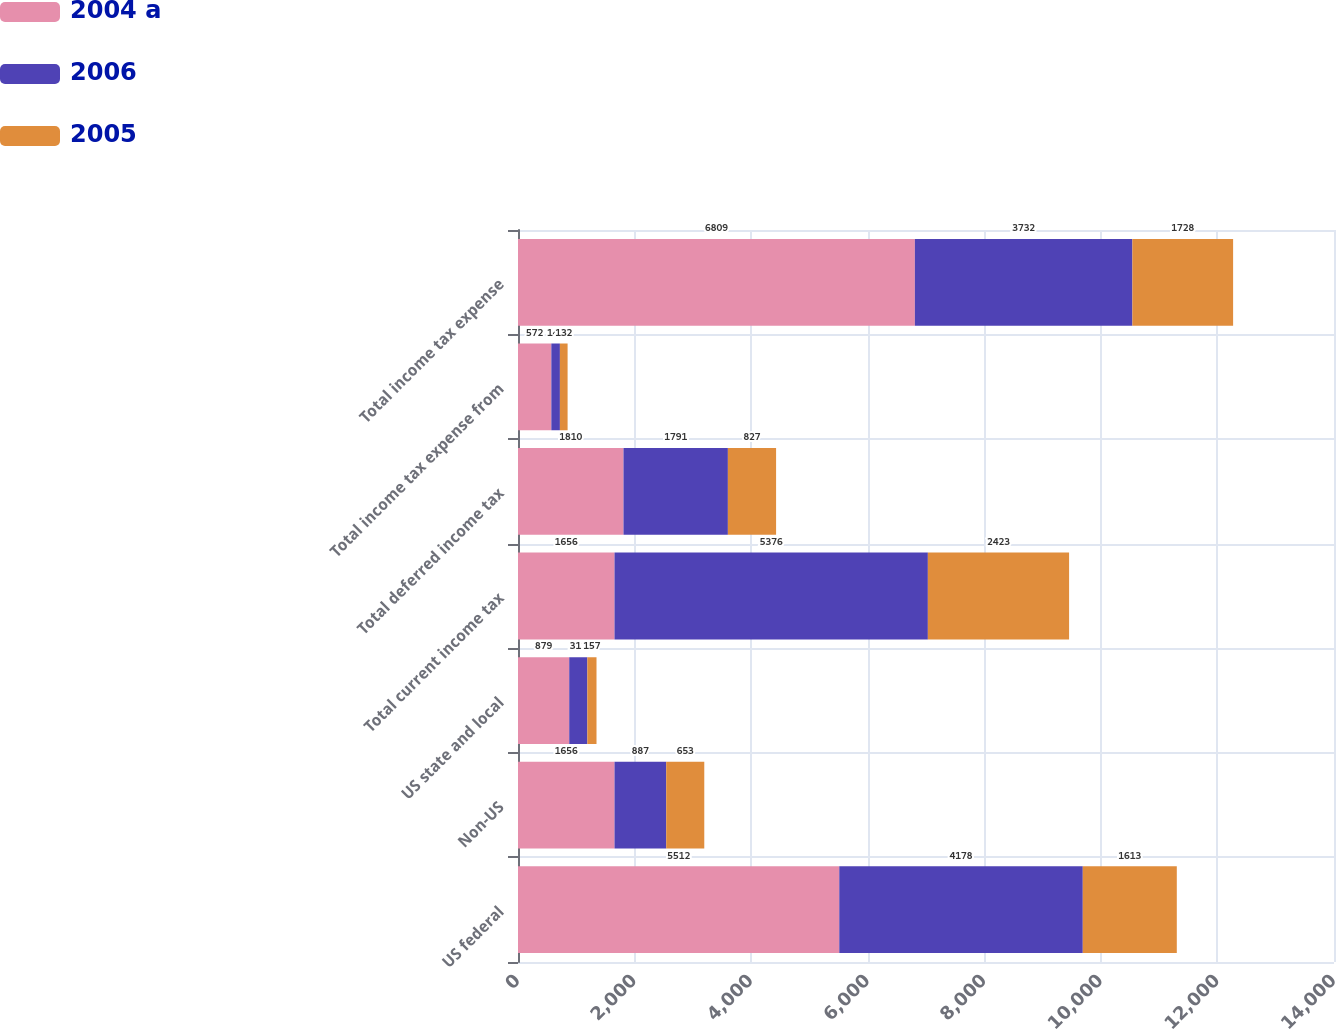<chart> <loc_0><loc_0><loc_500><loc_500><stacked_bar_chart><ecel><fcel>US federal<fcel>Non-US<fcel>US state and local<fcel>Total current income tax<fcel>Total deferred income tax<fcel>Total income tax expense from<fcel>Total income tax expense<nl><fcel>2004 a<fcel>5512<fcel>1656<fcel>879<fcel>1656<fcel>1810<fcel>572<fcel>6809<nl><fcel>2006<fcel>4178<fcel>887<fcel>311<fcel>5376<fcel>1791<fcel>147<fcel>3732<nl><fcel>2005<fcel>1613<fcel>653<fcel>157<fcel>2423<fcel>827<fcel>132<fcel>1728<nl></chart> 